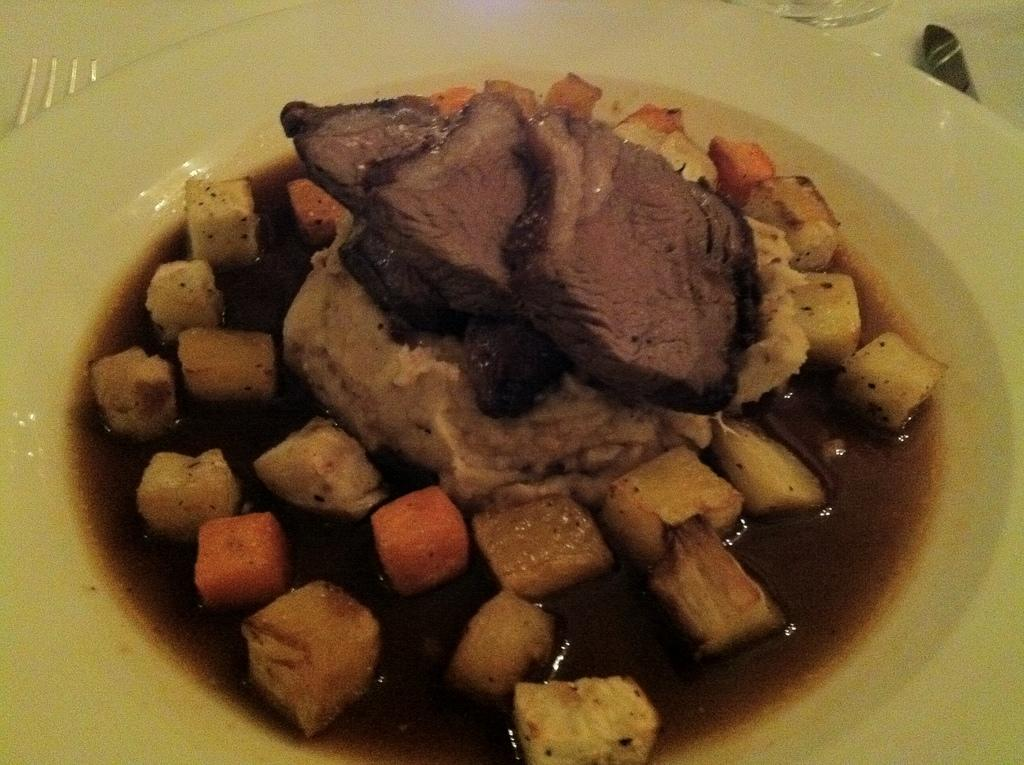What is on the plate in the image? There are food items in a plate in the image. What utensil is visible in the image? There is a fork visible in the image. Can you describe any other objects present in the image? Unfortunately, the provided facts do not give any information about other objects in the image. What type of spring can be seen in the image? There is no spring present in the image. What substance is being used to create the fog in the image? There is no fog present in the image. 